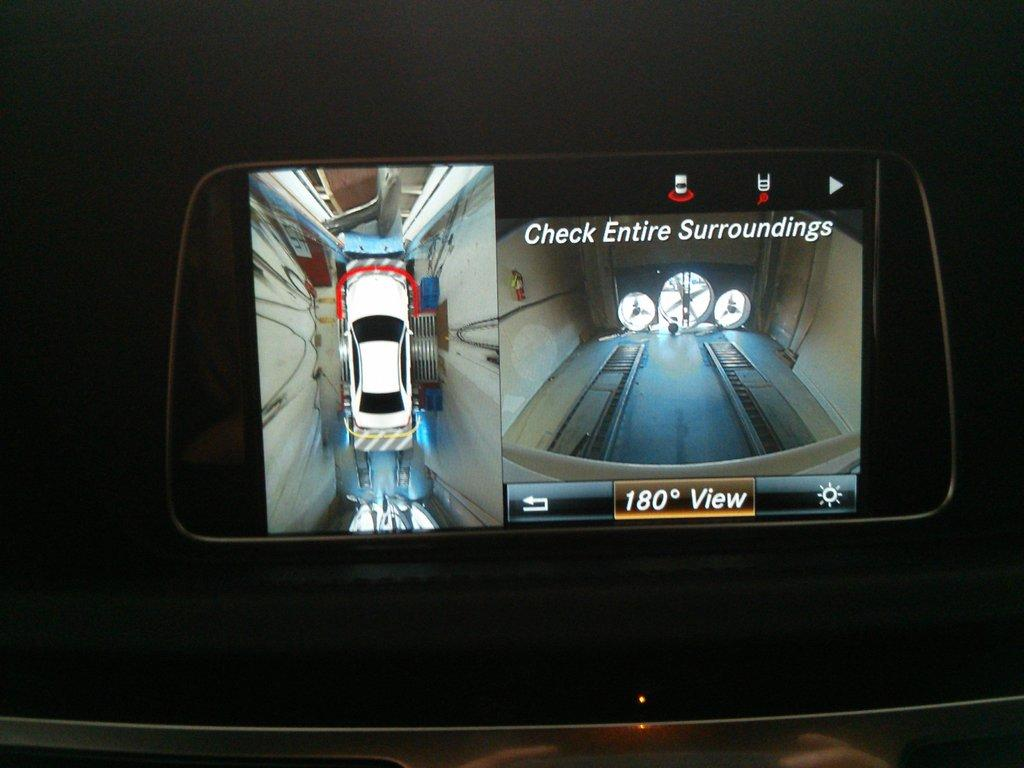What object is located in the center of the image? There is a phone in the center of the image. What is displayed on the phone's screen? The phone's screen shows a car image. How can you tell that the car image is a screenshot? The car image appears to be a screenshot, as it is displayed within the phone's interface. What type of fowl can be seen flying over the car image on the phone's screen? There is no fowl visible in the image, as the focus is on the phone and its screen. 